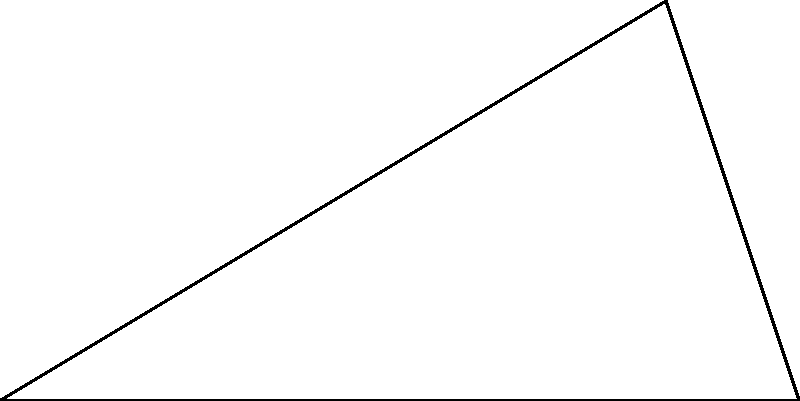A communications technology company needs to rotate a directional antenna to achieve optimal network coverage. The antenna is located at point O, and needs to be rotated to cover two key areas: point A, which is 3 km due east, and point B, which is 2.5 km away at a 31° angle north of east. What is the angle $\theta$ (in degrees) that the antenna should be rotated from its current east-facing position to be centered between points A and B for best coverage? To find the angle $\theta$ that centers the antenna between points A and B, we need to follow these steps:

1) First, we need to find the angle AOB. We can do this using the law of cosines:

   $\cos(\angle AOB) = \frac{OA^2 + OB^2 - AB^2}{2(OA)(OB)}$

2) We know OA = 3 km and OB = 2.5 km. We need to find AB:
   
   $AB^2 = OA^2 + OB^2 - 2(OA)(OB)\cos(31°)$
   $AB^2 = 3^2 + 2.5^2 - 2(3)(2.5)\cos(31°)$
   $AB^2 = 9 + 6.25 - 15\cos(31°)$
   $AB^2 = 15.25 - 12.84 = 2.41$
   $AB = \sqrt{2.41} \approx 1.55$ km

3) Now we can find $\angle AOB$:

   $\cos(\angle AOB) = \frac{3^2 + 2.5^2 - 1.55^2}{2(3)(2.5)}$
   $\cos(\angle AOB) = \frac{15.25 - 2.41}{15} = 0.856$
   $\angle AOB = \arccos(0.856) \approx 31°$

4) The angle we're looking for, $\theta$, is half of $\angle AOB$:

   $\theta = \frac{\angle AOB}{2} = \frac{31°}{2} = 15.5°$

Therefore, the antenna should be rotated 15.5° north of east to be centered between points A and B.
Answer: 15.5° 